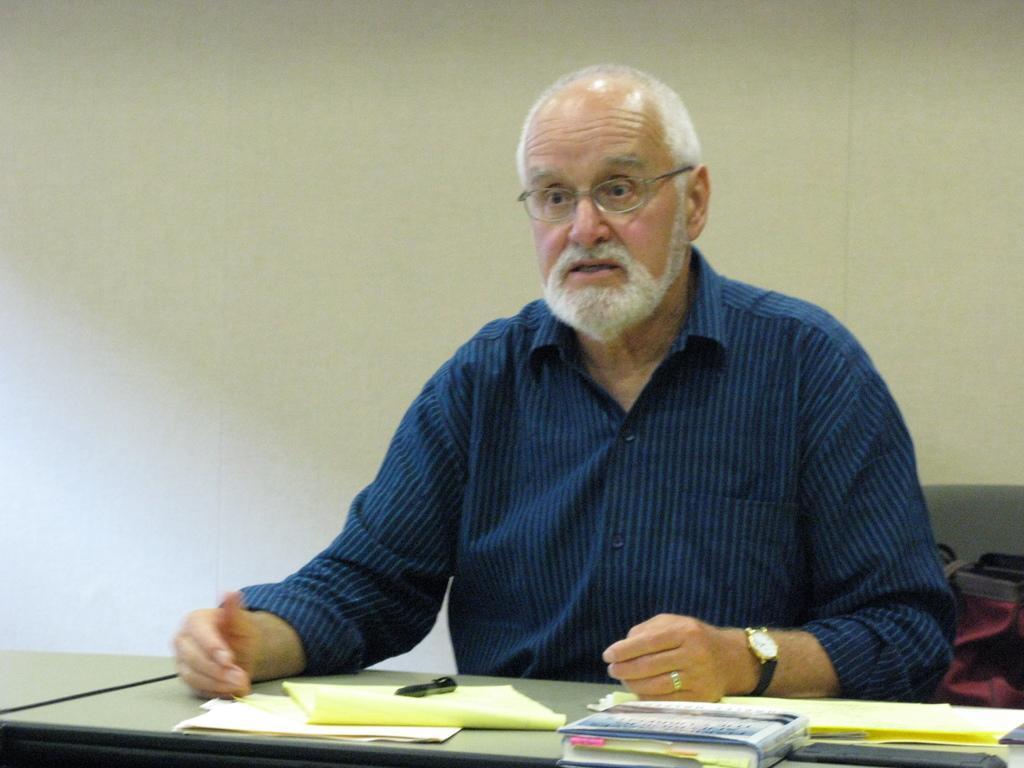Can you describe this image briefly? In this image I can see a man is sitting , he wore shirt, spectacles. There are papers and books on the table, behind him there is a wall. 